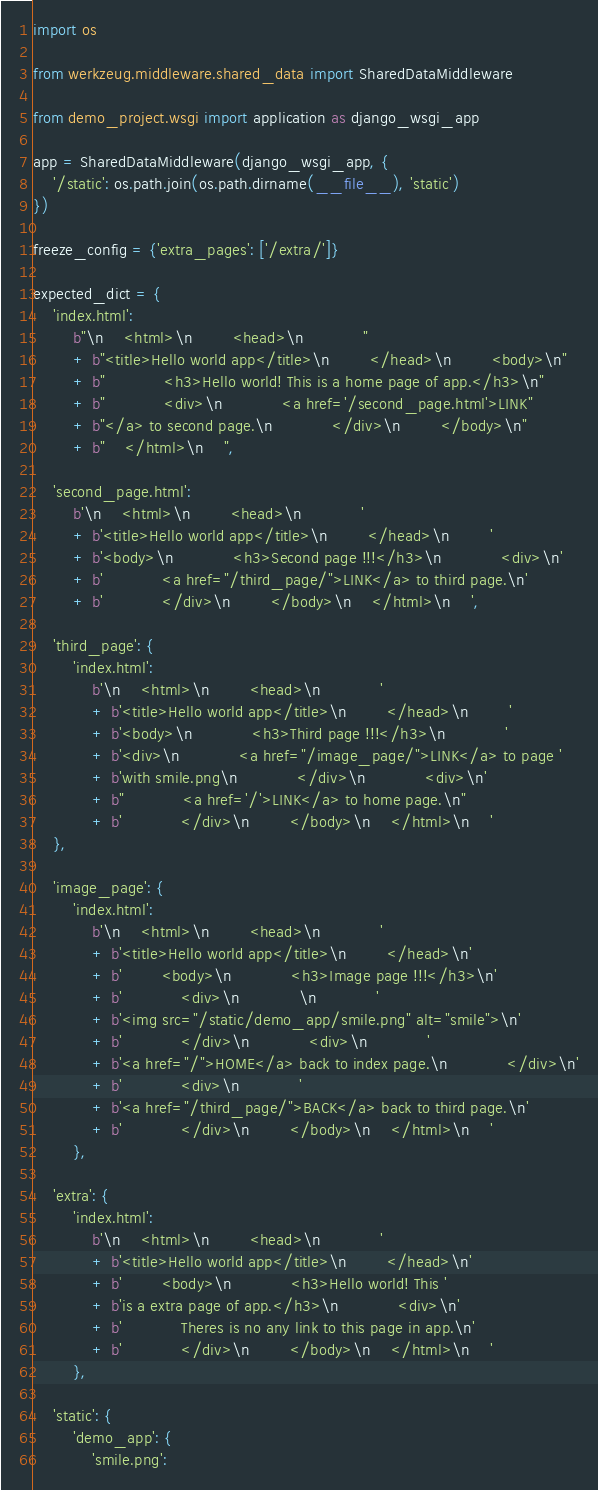<code> <loc_0><loc_0><loc_500><loc_500><_Python_>import os

from werkzeug.middleware.shared_data import SharedDataMiddleware

from demo_project.wsgi import application as django_wsgi_app

app = SharedDataMiddleware(django_wsgi_app, {
    '/static': os.path.join(os.path.dirname(__file__), 'static')
})

freeze_config = {'extra_pages': ['/extra/']}

expected_dict = {
    'index.html':
        b"\n    <html>\n        <head>\n            "
        + b"<title>Hello world app</title>\n        </head>\n        <body>\n"
        + b"            <h3>Hello world! This is a home page of app.</h3>\n"
        + b"            <div>\n            <a href='/second_page.html'>LINK"
        + b"</a> to second page.\n            </div>\n        </body>\n"
        + b"    </html>\n    ",

    'second_page.html':
        b'\n    <html>\n        <head>\n            '
        + b'<title>Hello world app</title>\n        </head>\n        '
        + b'<body>\n            <h3>Second page !!!</h3>\n            <div>\n'
        + b'            <a href="/third_page/">LINK</a> to third page.\n'
        + b'            </div>\n        </body>\n    </html>\n    ',

    'third_page': {
        'index.html':
            b'\n    <html>\n        <head>\n            '
            + b'<title>Hello world app</title>\n        </head>\n        '
            + b'<body>\n            <h3>Third page !!!</h3>\n            '
            + b'<div>\n            <a href="/image_page/">LINK</a> to page '
            + b'with smile.png\n            </div>\n            <div>\n'
            + b"            <a href='/'>LINK</a> to home page.\n"
            + b'            </div>\n        </body>\n    </html>\n    '
    },

    'image_page': {
        'index.html':
            b'\n    <html>\n        <head>\n            '
            + b'<title>Hello world app</title>\n        </head>\n'
            + b'        <body>\n            <h3>Image page !!!</h3>\n'
            + b'            <div>\n            \n            '
            + b'<img src="/static/demo_app/smile.png" alt="smile">\n'
            + b'            </div>\n            <div>\n            '
            + b'<a href="/">HOME</a> back to index page.\n            </div>\n'
            + b'            <div>\n            '
            + b'<a href="/third_page/">BACK</a> back to third page.\n'
            + b'            </div>\n        </body>\n    </html>\n    '
        },

    'extra': {
        'index.html':
            b'\n    <html>\n        <head>\n            '
            + b'<title>Hello world app</title>\n        </head>\n'
            + b'        <body>\n            <h3>Hello world! This '
            + b'is a extra page of app.</h3>\n            <div>\n'
            + b'            Theres is no any link to this page in app.\n'
            + b'            </div>\n        </body>\n    </html>\n    '
        },

    'static': {
        'demo_app': {
            'smile.png':</code> 